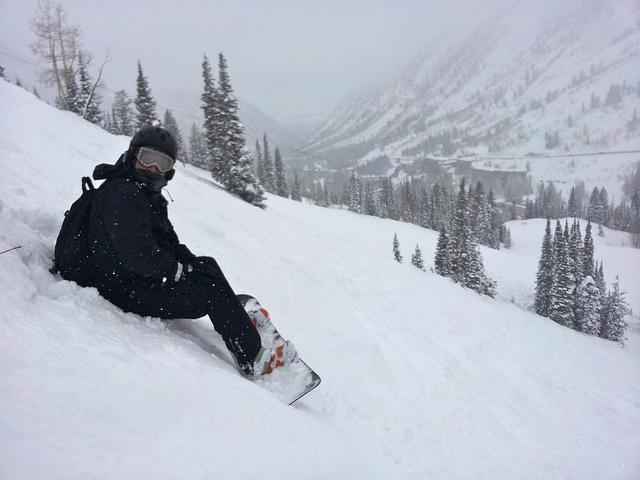How many people are there?
Keep it brief. 1. Is the person wearing a backpack?
Concise answer only. Yes. What is the man doing in this photo?
Write a very short answer. Sitting. What sport is the man practicing?
Concise answer only. Snowboarding. Is it snowing here?
Quick response, please. Yes. What is on the man's lap?
Give a very brief answer. Hands. What color are the lens on the mans goggles?
Be succinct. Clear. 